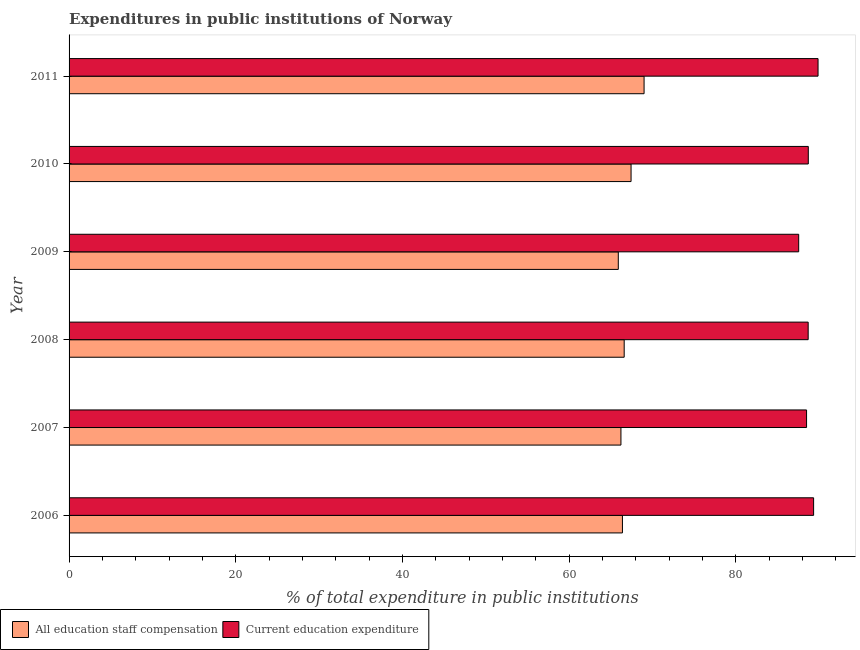Are the number of bars on each tick of the Y-axis equal?
Provide a succinct answer. Yes. How many bars are there on the 2nd tick from the top?
Offer a terse response. 2. What is the label of the 3rd group of bars from the top?
Ensure brevity in your answer.  2009. In how many cases, is the number of bars for a given year not equal to the number of legend labels?
Make the answer very short. 0. What is the expenditure in staff compensation in 2008?
Your response must be concise. 66.6. Across all years, what is the maximum expenditure in staff compensation?
Give a very brief answer. 68.99. Across all years, what is the minimum expenditure in staff compensation?
Make the answer very short. 65.89. In which year was the expenditure in education maximum?
Offer a very short reply. 2011. What is the total expenditure in education in the graph?
Ensure brevity in your answer.  532.56. What is the difference between the expenditure in staff compensation in 2007 and that in 2009?
Provide a succinct answer. 0.32. What is the difference between the expenditure in staff compensation in 2006 and the expenditure in education in 2007?
Keep it short and to the point. -22.09. What is the average expenditure in education per year?
Your response must be concise. 88.76. In the year 2011, what is the difference between the expenditure in education and expenditure in staff compensation?
Offer a terse response. 20.87. Is the expenditure in education in 2007 less than that in 2010?
Ensure brevity in your answer.  Yes. What is the difference between the highest and the second highest expenditure in education?
Your answer should be very brief. 0.53. What is the difference between the highest and the lowest expenditure in staff compensation?
Your response must be concise. 3.09. In how many years, is the expenditure in education greater than the average expenditure in education taken over all years?
Make the answer very short. 2. What does the 2nd bar from the top in 2011 represents?
Your answer should be compact. All education staff compensation. What does the 1st bar from the bottom in 2008 represents?
Make the answer very short. All education staff compensation. Are all the bars in the graph horizontal?
Offer a very short reply. Yes. Are the values on the major ticks of X-axis written in scientific E-notation?
Offer a terse response. No. Does the graph contain any zero values?
Provide a succinct answer. No. How are the legend labels stacked?
Ensure brevity in your answer.  Horizontal. What is the title of the graph?
Your answer should be compact. Expenditures in public institutions of Norway. Does "Unregistered firms" appear as one of the legend labels in the graph?
Your answer should be very brief. No. What is the label or title of the X-axis?
Your response must be concise. % of total expenditure in public institutions. What is the label or title of the Y-axis?
Your answer should be compact. Year. What is the % of total expenditure in public institutions in All education staff compensation in 2006?
Provide a succinct answer. 66.39. What is the % of total expenditure in public institutions in Current education expenditure in 2006?
Give a very brief answer. 89.33. What is the % of total expenditure in public institutions in All education staff compensation in 2007?
Offer a terse response. 66.21. What is the % of total expenditure in public institutions of Current education expenditure in 2007?
Ensure brevity in your answer.  88.48. What is the % of total expenditure in public institutions of All education staff compensation in 2008?
Provide a short and direct response. 66.6. What is the % of total expenditure in public institutions in Current education expenditure in 2008?
Ensure brevity in your answer.  88.67. What is the % of total expenditure in public institutions in All education staff compensation in 2009?
Your answer should be compact. 65.89. What is the % of total expenditure in public institutions of Current education expenditure in 2009?
Offer a terse response. 87.53. What is the % of total expenditure in public institutions of All education staff compensation in 2010?
Give a very brief answer. 67.42. What is the % of total expenditure in public institutions in Current education expenditure in 2010?
Offer a very short reply. 88.69. What is the % of total expenditure in public institutions in All education staff compensation in 2011?
Your answer should be compact. 68.99. What is the % of total expenditure in public institutions of Current education expenditure in 2011?
Your answer should be compact. 89.86. Across all years, what is the maximum % of total expenditure in public institutions in All education staff compensation?
Ensure brevity in your answer.  68.99. Across all years, what is the maximum % of total expenditure in public institutions in Current education expenditure?
Ensure brevity in your answer.  89.86. Across all years, what is the minimum % of total expenditure in public institutions in All education staff compensation?
Make the answer very short. 65.89. Across all years, what is the minimum % of total expenditure in public institutions in Current education expenditure?
Your response must be concise. 87.53. What is the total % of total expenditure in public institutions of All education staff compensation in the graph?
Ensure brevity in your answer.  401.5. What is the total % of total expenditure in public institutions of Current education expenditure in the graph?
Offer a very short reply. 532.56. What is the difference between the % of total expenditure in public institutions of All education staff compensation in 2006 and that in 2007?
Keep it short and to the point. 0.18. What is the difference between the % of total expenditure in public institutions of Current education expenditure in 2006 and that in 2007?
Your answer should be very brief. 0.85. What is the difference between the % of total expenditure in public institutions in All education staff compensation in 2006 and that in 2008?
Give a very brief answer. -0.21. What is the difference between the % of total expenditure in public institutions of Current education expenditure in 2006 and that in 2008?
Ensure brevity in your answer.  0.65. What is the difference between the % of total expenditure in public institutions in All education staff compensation in 2006 and that in 2009?
Make the answer very short. 0.5. What is the difference between the % of total expenditure in public institutions in Current education expenditure in 2006 and that in 2009?
Make the answer very short. 1.79. What is the difference between the % of total expenditure in public institutions in All education staff compensation in 2006 and that in 2010?
Your response must be concise. -1.03. What is the difference between the % of total expenditure in public institutions in Current education expenditure in 2006 and that in 2010?
Your answer should be compact. 0.64. What is the difference between the % of total expenditure in public institutions of All education staff compensation in 2006 and that in 2011?
Ensure brevity in your answer.  -2.59. What is the difference between the % of total expenditure in public institutions in Current education expenditure in 2006 and that in 2011?
Provide a short and direct response. -0.53. What is the difference between the % of total expenditure in public institutions in All education staff compensation in 2007 and that in 2008?
Keep it short and to the point. -0.39. What is the difference between the % of total expenditure in public institutions in Current education expenditure in 2007 and that in 2008?
Keep it short and to the point. -0.19. What is the difference between the % of total expenditure in public institutions of All education staff compensation in 2007 and that in 2009?
Your answer should be very brief. 0.32. What is the difference between the % of total expenditure in public institutions of Current education expenditure in 2007 and that in 2009?
Offer a terse response. 0.95. What is the difference between the % of total expenditure in public institutions of All education staff compensation in 2007 and that in 2010?
Your answer should be very brief. -1.21. What is the difference between the % of total expenditure in public institutions of Current education expenditure in 2007 and that in 2010?
Offer a terse response. -0.21. What is the difference between the % of total expenditure in public institutions in All education staff compensation in 2007 and that in 2011?
Ensure brevity in your answer.  -2.78. What is the difference between the % of total expenditure in public institutions of Current education expenditure in 2007 and that in 2011?
Your answer should be compact. -1.38. What is the difference between the % of total expenditure in public institutions of All education staff compensation in 2008 and that in 2009?
Your answer should be very brief. 0.71. What is the difference between the % of total expenditure in public institutions in Current education expenditure in 2008 and that in 2009?
Give a very brief answer. 1.14. What is the difference between the % of total expenditure in public institutions in All education staff compensation in 2008 and that in 2010?
Provide a short and direct response. -0.82. What is the difference between the % of total expenditure in public institutions in Current education expenditure in 2008 and that in 2010?
Offer a terse response. -0.01. What is the difference between the % of total expenditure in public institutions of All education staff compensation in 2008 and that in 2011?
Ensure brevity in your answer.  -2.38. What is the difference between the % of total expenditure in public institutions of Current education expenditure in 2008 and that in 2011?
Ensure brevity in your answer.  -1.18. What is the difference between the % of total expenditure in public institutions in All education staff compensation in 2009 and that in 2010?
Your answer should be compact. -1.53. What is the difference between the % of total expenditure in public institutions of Current education expenditure in 2009 and that in 2010?
Your answer should be compact. -1.15. What is the difference between the % of total expenditure in public institutions of All education staff compensation in 2009 and that in 2011?
Keep it short and to the point. -3.09. What is the difference between the % of total expenditure in public institutions of Current education expenditure in 2009 and that in 2011?
Your answer should be compact. -2.32. What is the difference between the % of total expenditure in public institutions of All education staff compensation in 2010 and that in 2011?
Your response must be concise. -1.56. What is the difference between the % of total expenditure in public institutions of Current education expenditure in 2010 and that in 2011?
Your answer should be compact. -1.17. What is the difference between the % of total expenditure in public institutions in All education staff compensation in 2006 and the % of total expenditure in public institutions in Current education expenditure in 2007?
Make the answer very short. -22.09. What is the difference between the % of total expenditure in public institutions of All education staff compensation in 2006 and the % of total expenditure in public institutions of Current education expenditure in 2008?
Offer a terse response. -22.28. What is the difference between the % of total expenditure in public institutions in All education staff compensation in 2006 and the % of total expenditure in public institutions in Current education expenditure in 2009?
Your response must be concise. -21.14. What is the difference between the % of total expenditure in public institutions in All education staff compensation in 2006 and the % of total expenditure in public institutions in Current education expenditure in 2010?
Your answer should be compact. -22.3. What is the difference between the % of total expenditure in public institutions in All education staff compensation in 2006 and the % of total expenditure in public institutions in Current education expenditure in 2011?
Provide a succinct answer. -23.47. What is the difference between the % of total expenditure in public institutions of All education staff compensation in 2007 and the % of total expenditure in public institutions of Current education expenditure in 2008?
Your response must be concise. -22.46. What is the difference between the % of total expenditure in public institutions in All education staff compensation in 2007 and the % of total expenditure in public institutions in Current education expenditure in 2009?
Provide a succinct answer. -21.32. What is the difference between the % of total expenditure in public institutions in All education staff compensation in 2007 and the % of total expenditure in public institutions in Current education expenditure in 2010?
Make the answer very short. -22.48. What is the difference between the % of total expenditure in public institutions in All education staff compensation in 2007 and the % of total expenditure in public institutions in Current education expenditure in 2011?
Ensure brevity in your answer.  -23.65. What is the difference between the % of total expenditure in public institutions in All education staff compensation in 2008 and the % of total expenditure in public institutions in Current education expenditure in 2009?
Offer a terse response. -20.93. What is the difference between the % of total expenditure in public institutions in All education staff compensation in 2008 and the % of total expenditure in public institutions in Current education expenditure in 2010?
Make the answer very short. -22.09. What is the difference between the % of total expenditure in public institutions of All education staff compensation in 2008 and the % of total expenditure in public institutions of Current education expenditure in 2011?
Give a very brief answer. -23.26. What is the difference between the % of total expenditure in public institutions in All education staff compensation in 2009 and the % of total expenditure in public institutions in Current education expenditure in 2010?
Give a very brief answer. -22.8. What is the difference between the % of total expenditure in public institutions in All education staff compensation in 2009 and the % of total expenditure in public institutions in Current education expenditure in 2011?
Provide a succinct answer. -23.97. What is the difference between the % of total expenditure in public institutions of All education staff compensation in 2010 and the % of total expenditure in public institutions of Current education expenditure in 2011?
Give a very brief answer. -22.43. What is the average % of total expenditure in public institutions in All education staff compensation per year?
Ensure brevity in your answer.  66.92. What is the average % of total expenditure in public institutions in Current education expenditure per year?
Provide a succinct answer. 88.76. In the year 2006, what is the difference between the % of total expenditure in public institutions of All education staff compensation and % of total expenditure in public institutions of Current education expenditure?
Make the answer very short. -22.94. In the year 2007, what is the difference between the % of total expenditure in public institutions of All education staff compensation and % of total expenditure in public institutions of Current education expenditure?
Your response must be concise. -22.27. In the year 2008, what is the difference between the % of total expenditure in public institutions of All education staff compensation and % of total expenditure in public institutions of Current education expenditure?
Make the answer very short. -22.07. In the year 2009, what is the difference between the % of total expenditure in public institutions in All education staff compensation and % of total expenditure in public institutions in Current education expenditure?
Your response must be concise. -21.64. In the year 2010, what is the difference between the % of total expenditure in public institutions in All education staff compensation and % of total expenditure in public institutions in Current education expenditure?
Offer a very short reply. -21.26. In the year 2011, what is the difference between the % of total expenditure in public institutions in All education staff compensation and % of total expenditure in public institutions in Current education expenditure?
Provide a succinct answer. -20.87. What is the ratio of the % of total expenditure in public institutions in Current education expenditure in 2006 to that in 2007?
Your response must be concise. 1.01. What is the ratio of the % of total expenditure in public institutions in All education staff compensation in 2006 to that in 2008?
Provide a succinct answer. 1. What is the ratio of the % of total expenditure in public institutions in Current education expenditure in 2006 to that in 2008?
Your answer should be very brief. 1.01. What is the ratio of the % of total expenditure in public institutions of All education staff compensation in 2006 to that in 2009?
Offer a terse response. 1.01. What is the ratio of the % of total expenditure in public institutions in Current education expenditure in 2006 to that in 2009?
Offer a very short reply. 1.02. What is the ratio of the % of total expenditure in public institutions of All education staff compensation in 2006 to that in 2010?
Offer a very short reply. 0.98. What is the ratio of the % of total expenditure in public institutions in All education staff compensation in 2006 to that in 2011?
Your answer should be very brief. 0.96. What is the ratio of the % of total expenditure in public institutions of Current education expenditure in 2007 to that in 2008?
Offer a terse response. 1. What is the ratio of the % of total expenditure in public institutions of Current education expenditure in 2007 to that in 2009?
Make the answer very short. 1.01. What is the ratio of the % of total expenditure in public institutions of All education staff compensation in 2007 to that in 2010?
Ensure brevity in your answer.  0.98. What is the ratio of the % of total expenditure in public institutions of All education staff compensation in 2007 to that in 2011?
Ensure brevity in your answer.  0.96. What is the ratio of the % of total expenditure in public institutions of Current education expenditure in 2007 to that in 2011?
Offer a very short reply. 0.98. What is the ratio of the % of total expenditure in public institutions of All education staff compensation in 2008 to that in 2009?
Provide a short and direct response. 1.01. What is the ratio of the % of total expenditure in public institutions of Current education expenditure in 2008 to that in 2009?
Provide a short and direct response. 1.01. What is the ratio of the % of total expenditure in public institutions in All education staff compensation in 2008 to that in 2011?
Offer a very short reply. 0.97. What is the ratio of the % of total expenditure in public institutions of Current education expenditure in 2008 to that in 2011?
Your answer should be very brief. 0.99. What is the ratio of the % of total expenditure in public institutions of All education staff compensation in 2009 to that in 2010?
Your answer should be very brief. 0.98. What is the ratio of the % of total expenditure in public institutions in Current education expenditure in 2009 to that in 2010?
Offer a terse response. 0.99. What is the ratio of the % of total expenditure in public institutions of All education staff compensation in 2009 to that in 2011?
Provide a short and direct response. 0.96. What is the ratio of the % of total expenditure in public institutions in Current education expenditure in 2009 to that in 2011?
Your answer should be very brief. 0.97. What is the ratio of the % of total expenditure in public institutions of All education staff compensation in 2010 to that in 2011?
Your response must be concise. 0.98. What is the difference between the highest and the second highest % of total expenditure in public institutions in All education staff compensation?
Your answer should be very brief. 1.56. What is the difference between the highest and the second highest % of total expenditure in public institutions in Current education expenditure?
Make the answer very short. 0.53. What is the difference between the highest and the lowest % of total expenditure in public institutions of All education staff compensation?
Ensure brevity in your answer.  3.09. What is the difference between the highest and the lowest % of total expenditure in public institutions in Current education expenditure?
Make the answer very short. 2.32. 